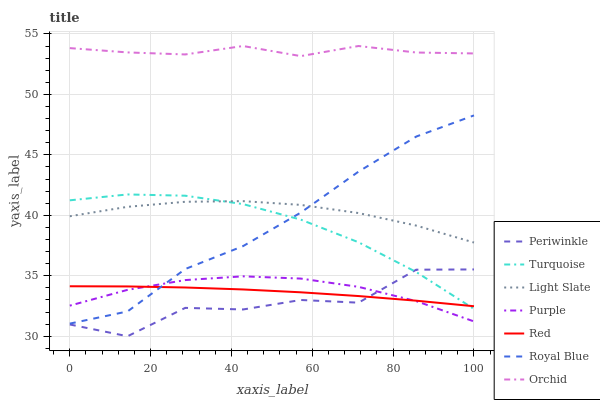Does Periwinkle have the minimum area under the curve?
Answer yes or no. Yes. Does Orchid have the maximum area under the curve?
Answer yes or no. Yes. Does Royal Blue have the minimum area under the curve?
Answer yes or no. No. Does Royal Blue have the maximum area under the curve?
Answer yes or no. No. Is Red the smoothest?
Answer yes or no. Yes. Is Periwinkle the roughest?
Answer yes or no. Yes. Is Royal Blue the smoothest?
Answer yes or no. No. Is Royal Blue the roughest?
Answer yes or no. No. Does Periwinkle have the lowest value?
Answer yes or no. Yes. Does Royal Blue have the lowest value?
Answer yes or no. No. Does Orchid have the highest value?
Answer yes or no. Yes. Does Royal Blue have the highest value?
Answer yes or no. No. Is Red less than Orchid?
Answer yes or no. Yes. Is Light Slate greater than Red?
Answer yes or no. Yes. Does Red intersect Royal Blue?
Answer yes or no. Yes. Is Red less than Royal Blue?
Answer yes or no. No. Is Red greater than Royal Blue?
Answer yes or no. No. Does Red intersect Orchid?
Answer yes or no. No. 